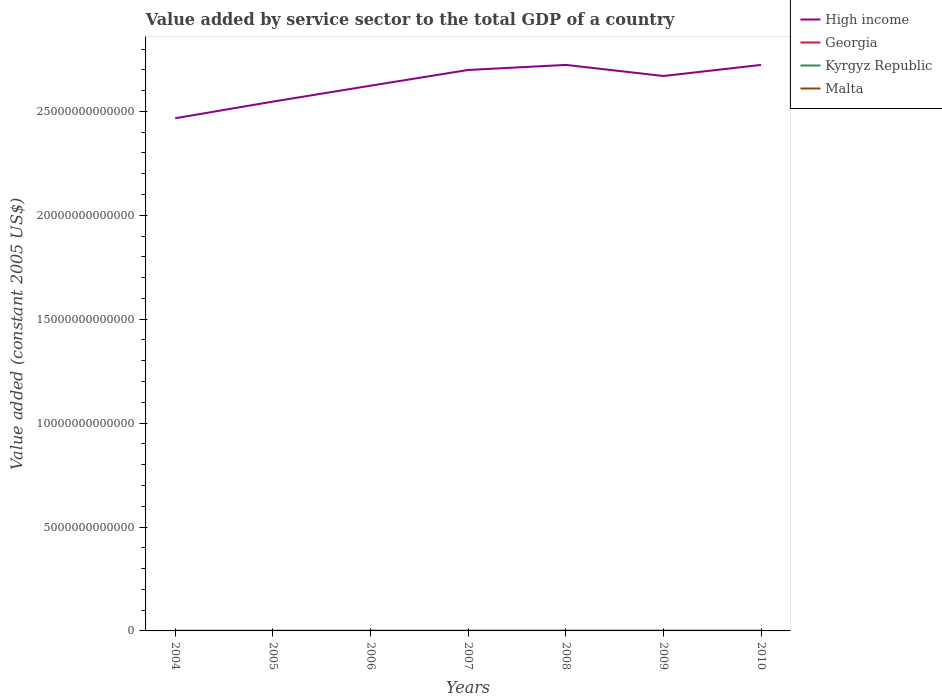Across all years, what is the maximum value added by service sector in High income?
Offer a very short reply. 2.47e+13. In which year was the value added by service sector in Kyrgyz Republic maximum?
Make the answer very short. 2004. What is the total value added by service sector in Kyrgyz Republic in the graph?
Provide a short and direct response. -6.95e+08. What is the difference between the highest and the second highest value added by service sector in High income?
Provide a succinct answer. 2.57e+12. What is the difference between the highest and the lowest value added by service sector in Malta?
Make the answer very short. 3. Is the value added by service sector in Kyrgyz Republic strictly greater than the value added by service sector in High income over the years?
Provide a short and direct response. Yes. How many lines are there?
Make the answer very short. 4. How many years are there in the graph?
Offer a terse response. 7. What is the difference between two consecutive major ticks on the Y-axis?
Keep it short and to the point. 5.00e+12. Where does the legend appear in the graph?
Your answer should be very brief. Top right. How many legend labels are there?
Your answer should be compact. 4. What is the title of the graph?
Offer a terse response. Value added by service sector to the total GDP of a country. What is the label or title of the Y-axis?
Ensure brevity in your answer.  Value added (constant 2005 US$). What is the Value added (constant 2005 US$) in High income in 2004?
Your answer should be very brief. 2.47e+13. What is the Value added (constant 2005 US$) of Georgia in 2004?
Offer a terse response. 2.95e+09. What is the Value added (constant 2005 US$) in Kyrgyz Republic in 2004?
Offer a very short reply. 9.07e+08. What is the Value added (constant 2005 US$) of Malta in 2004?
Your answer should be very brief. 2.93e+09. What is the Value added (constant 2005 US$) in High income in 2005?
Your answer should be very brief. 2.55e+13. What is the Value added (constant 2005 US$) in Georgia in 2005?
Offer a very short reply. 3.20e+09. What is the Value added (constant 2005 US$) of Kyrgyz Republic in 2005?
Offer a very short reply. 1.00e+09. What is the Value added (constant 2005 US$) in Malta in 2005?
Make the answer very short. 3.08e+09. What is the Value added (constant 2005 US$) in High income in 2006?
Your response must be concise. 2.62e+13. What is the Value added (constant 2005 US$) in Georgia in 2006?
Your response must be concise. 3.76e+09. What is the Value added (constant 2005 US$) in Kyrgyz Republic in 2006?
Your response must be concise. 1.24e+09. What is the Value added (constant 2005 US$) in Malta in 2006?
Your answer should be very brief. 3.14e+09. What is the Value added (constant 2005 US$) in High income in 2007?
Provide a short and direct response. 2.70e+13. What is the Value added (constant 2005 US$) of Georgia in 2007?
Give a very brief answer. 4.19e+09. What is the Value added (constant 2005 US$) in Kyrgyz Republic in 2007?
Provide a short and direct response. 1.42e+09. What is the Value added (constant 2005 US$) in Malta in 2007?
Offer a terse response. 3.33e+09. What is the Value added (constant 2005 US$) in High income in 2008?
Offer a very short reply. 2.72e+13. What is the Value added (constant 2005 US$) in Georgia in 2008?
Your answer should be very brief. 4.43e+09. What is the Value added (constant 2005 US$) of Kyrgyz Republic in 2008?
Provide a short and direct response. 1.60e+09. What is the Value added (constant 2005 US$) in Malta in 2008?
Give a very brief answer. 3.62e+09. What is the Value added (constant 2005 US$) in High income in 2009?
Keep it short and to the point. 2.67e+13. What is the Value added (constant 2005 US$) in Georgia in 2009?
Your response must be concise. 4.26e+09. What is the Value added (constant 2005 US$) in Kyrgyz Republic in 2009?
Provide a succinct answer. 1.62e+09. What is the Value added (constant 2005 US$) in Malta in 2009?
Keep it short and to the point. 3.69e+09. What is the Value added (constant 2005 US$) in High income in 2010?
Give a very brief answer. 2.72e+13. What is the Value added (constant 2005 US$) in Georgia in 2010?
Ensure brevity in your answer.  4.74e+09. What is the Value added (constant 2005 US$) in Kyrgyz Republic in 2010?
Your answer should be compact. 1.62e+09. What is the Value added (constant 2005 US$) in Malta in 2010?
Offer a terse response. 3.84e+09. Across all years, what is the maximum Value added (constant 2005 US$) in High income?
Offer a terse response. 2.72e+13. Across all years, what is the maximum Value added (constant 2005 US$) in Georgia?
Offer a terse response. 4.74e+09. Across all years, what is the maximum Value added (constant 2005 US$) in Kyrgyz Republic?
Your response must be concise. 1.62e+09. Across all years, what is the maximum Value added (constant 2005 US$) in Malta?
Make the answer very short. 3.84e+09. Across all years, what is the minimum Value added (constant 2005 US$) in High income?
Keep it short and to the point. 2.47e+13. Across all years, what is the minimum Value added (constant 2005 US$) of Georgia?
Your response must be concise. 2.95e+09. Across all years, what is the minimum Value added (constant 2005 US$) of Kyrgyz Republic?
Offer a very short reply. 9.07e+08. Across all years, what is the minimum Value added (constant 2005 US$) in Malta?
Your response must be concise. 2.93e+09. What is the total Value added (constant 2005 US$) of High income in the graph?
Your answer should be compact. 1.85e+14. What is the total Value added (constant 2005 US$) in Georgia in the graph?
Provide a short and direct response. 2.75e+1. What is the total Value added (constant 2005 US$) in Kyrgyz Republic in the graph?
Make the answer very short. 9.42e+09. What is the total Value added (constant 2005 US$) in Malta in the graph?
Provide a succinct answer. 2.36e+1. What is the difference between the Value added (constant 2005 US$) in High income in 2004 and that in 2005?
Keep it short and to the point. -8.01e+11. What is the difference between the Value added (constant 2005 US$) in Georgia in 2004 and that in 2005?
Your answer should be very brief. -2.54e+08. What is the difference between the Value added (constant 2005 US$) in Kyrgyz Republic in 2004 and that in 2005?
Offer a terse response. -9.48e+07. What is the difference between the Value added (constant 2005 US$) in Malta in 2004 and that in 2005?
Your answer should be compact. -1.43e+08. What is the difference between the Value added (constant 2005 US$) of High income in 2004 and that in 2006?
Provide a short and direct response. -1.57e+12. What is the difference between the Value added (constant 2005 US$) in Georgia in 2004 and that in 2006?
Provide a succinct answer. -8.07e+08. What is the difference between the Value added (constant 2005 US$) of Kyrgyz Republic in 2004 and that in 2006?
Your answer should be compact. -3.38e+08. What is the difference between the Value added (constant 2005 US$) in Malta in 2004 and that in 2006?
Provide a succinct answer. -2.05e+08. What is the difference between the Value added (constant 2005 US$) in High income in 2004 and that in 2007?
Give a very brief answer. -2.32e+12. What is the difference between the Value added (constant 2005 US$) of Georgia in 2004 and that in 2007?
Ensure brevity in your answer.  -1.24e+09. What is the difference between the Value added (constant 2005 US$) of Kyrgyz Republic in 2004 and that in 2007?
Your answer should be very brief. -5.14e+08. What is the difference between the Value added (constant 2005 US$) in Malta in 2004 and that in 2007?
Provide a succinct answer. -3.94e+08. What is the difference between the Value added (constant 2005 US$) in High income in 2004 and that in 2008?
Make the answer very short. -2.57e+12. What is the difference between the Value added (constant 2005 US$) in Georgia in 2004 and that in 2008?
Provide a succinct answer. -1.48e+09. What is the difference between the Value added (constant 2005 US$) of Kyrgyz Republic in 2004 and that in 2008?
Provide a succinct answer. -6.95e+08. What is the difference between the Value added (constant 2005 US$) of Malta in 2004 and that in 2008?
Your answer should be very brief. -6.84e+08. What is the difference between the Value added (constant 2005 US$) in High income in 2004 and that in 2009?
Provide a short and direct response. -2.03e+12. What is the difference between the Value added (constant 2005 US$) of Georgia in 2004 and that in 2009?
Make the answer very short. -1.31e+09. What is the difference between the Value added (constant 2005 US$) in Kyrgyz Republic in 2004 and that in 2009?
Offer a very short reply. -7.13e+08. What is the difference between the Value added (constant 2005 US$) in Malta in 2004 and that in 2009?
Ensure brevity in your answer.  -7.51e+08. What is the difference between the Value added (constant 2005 US$) in High income in 2004 and that in 2010?
Offer a very short reply. -2.57e+12. What is the difference between the Value added (constant 2005 US$) of Georgia in 2004 and that in 2010?
Your answer should be compact. -1.79e+09. What is the difference between the Value added (constant 2005 US$) in Kyrgyz Republic in 2004 and that in 2010?
Offer a very short reply. -7.16e+08. What is the difference between the Value added (constant 2005 US$) in Malta in 2004 and that in 2010?
Provide a short and direct response. -9.04e+08. What is the difference between the Value added (constant 2005 US$) in High income in 2005 and that in 2006?
Your response must be concise. -7.66e+11. What is the difference between the Value added (constant 2005 US$) of Georgia in 2005 and that in 2006?
Provide a succinct answer. -5.54e+08. What is the difference between the Value added (constant 2005 US$) in Kyrgyz Republic in 2005 and that in 2006?
Provide a short and direct response. -2.43e+08. What is the difference between the Value added (constant 2005 US$) of Malta in 2005 and that in 2006?
Keep it short and to the point. -6.24e+07. What is the difference between the Value added (constant 2005 US$) in High income in 2005 and that in 2007?
Your answer should be very brief. -1.52e+12. What is the difference between the Value added (constant 2005 US$) in Georgia in 2005 and that in 2007?
Make the answer very short. -9.89e+08. What is the difference between the Value added (constant 2005 US$) in Kyrgyz Republic in 2005 and that in 2007?
Your answer should be compact. -4.19e+08. What is the difference between the Value added (constant 2005 US$) in Malta in 2005 and that in 2007?
Keep it short and to the point. -2.51e+08. What is the difference between the Value added (constant 2005 US$) in High income in 2005 and that in 2008?
Make the answer very short. -1.77e+12. What is the difference between the Value added (constant 2005 US$) of Georgia in 2005 and that in 2008?
Make the answer very short. -1.22e+09. What is the difference between the Value added (constant 2005 US$) in Kyrgyz Republic in 2005 and that in 2008?
Offer a terse response. -6.00e+08. What is the difference between the Value added (constant 2005 US$) of Malta in 2005 and that in 2008?
Give a very brief answer. -5.41e+08. What is the difference between the Value added (constant 2005 US$) of High income in 2005 and that in 2009?
Make the answer very short. -1.23e+12. What is the difference between the Value added (constant 2005 US$) in Georgia in 2005 and that in 2009?
Make the answer very short. -1.05e+09. What is the difference between the Value added (constant 2005 US$) in Kyrgyz Republic in 2005 and that in 2009?
Offer a terse response. -6.18e+08. What is the difference between the Value added (constant 2005 US$) of Malta in 2005 and that in 2009?
Provide a short and direct response. -6.08e+08. What is the difference between the Value added (constant 2005 US$) of High income in 2005 and that in 2010?
Make the answer very short. -1.77e+12. What is the difference between the Value added (constant 2005 US$) of Georgia in 2005 and that in 2010?
Your answer should be very brief. -1.53e+09. What is the difference between the Value added (constant 2005 US$) of Kyrgyz Republic in 2005 and that in 2010?
Your response must be concise. -6.21e+08. What is the difference between the Value added (constant 2005 US$) of Malta in 2005 and that in 2010?
Your answer should be very brief. -7.62e+08. What is the difference between the Value added (constant 2005 US$) in High income in 2006 and that in 2007?
Your answer should be very brief. -7.56e+11. What is the difference between the Value added (constant 2005 US$) in Georgia in 2006 and that in 2007?
Provide a succinct answer. -4.35e+08. What is the difference between the Value added (constant 2005 US$) of Kyrgyz Republic in 2006 and that in 2007?
Provide a succinct answer. -1.77e+08. What is the difference between the Value added (constant 2005 US$) in Malta in 2006 and that in 2007?
Keep it short and to the point. -1.89e+08. What is the difference between the Value added (constant 2005 US$) in High income in 2006 and that in 2008?
Offer a very short reply. -1.00e+12. What is the difference between the Value added (constant 2005 US$) in Georgia in 2006 and that in 2008?
Your answer should be very brief. -6.70e+08. What is the difference between the Value added (constant 2005 US$) in Kyrgyz Republic in 2006 and that in 2008?
Provide a short and direct response. -3.57e+08. What is the difference between the Value added (constant 2005 US$) in Malta in 2006 and that in 2008?
Ensure brevity in your answer.  -4.79e+08. What is the difference between the Value added (constant 2005 US$) of High income in 2006 and that in 2009?
Offer a terse response. -4.66e+11. What is the difference between the Value added (constant 2005 US$) of Georgia in 2006 and that in 2009?
Provide a short and direct response. -5.00e+08. What is the difference between the Value added (constant 2005 US$) of Kyrgyz Republic in 2006 and that in 2009?
Keep it short and to the point. -3.75e+08. What is the difference between the Value added (constant 2005 US$) of Malta in 2006 and that in 2009?
Your answer should be very brief. -5.46e+08. What is the difference between the Value added (constant 2005 US$) of High income in 2006 and that in 2010?
Your response must be concise. -1.00e+12. What is the difference between the Value added (constant 2005 US$) in Georgia in 2006 and that in 2010?
Make the answer very short. -9.78e+08. What is the difference between the Value added (constant 2005 US$) of Kyrgyz Republic in 2006 and that in 2010?
Provide a short and direct response. -3.79e+08. What is the difference between the Value added (constant 2005 US$) in Malta in 2006 and that in 2010?
Your answer should be compact. -6.99e+08. What is the difference between the Value added (constant 2005 US$) of High income in 2007 and that in 2008?
Keep it short and to the point. -2.44e+11. What is the difference between the Value added (constant 2005 US$) of Georgia in 2007 and that in 2008?
Your answer should be very brief. -2.35e+08. What is the difference between the Value added (constant 2005 US$) of Kyrgyz Republic in 2007 and that in 2008?
Your response must be concise. -1.81e+08. What is the difference between the Value added (constant 2005 US$) in Malta in 2007 and that in 2008?
Provide a succinct answer. -2.90e+08. What is the difference between the Value added (constant 2005 US$) of High income in 2007 and that in 2009?
Your response must be concise. 2.90e+11. What is the difference between the Value added (constant 2005 US$) in Georgia in 2007 and that in 2009?
Your answer should be very brief. -6.50e+07. What is the difference between the Value added (constant 2005 US$) of Kyrgyz Republic in 2007 and that in 2009?
Provide a succinct answer. -1.99e+08. What is the difference between the Value added (constant 2005 US$) of Malta in 2007 and that in 2009?
Offer a very short reply. -3.57e+08. What is the difference between the Value added (constant 2005 US$) in High income in 2007 and that in 2010?
Your response must be concise. -2.45e+11. What is the difference between the Value added (constant 2005 US$) of Georgia in 2007 and that in 2010?
Your answer should be compact. -5.43e+08. What is the difference between the Value added (constant 2005 US$) of Kyrgyz Republic in 2007 and that in 2010?
Make the answer very short. -2.02e+08. What is the difference between the Value added (constant 2005 US$) of Malta in 2007 and that in 2010?
Your answer should be very brief. -5.10e+08. What is the difference between the Value added (constant 2005 US$) of High income in 2008 and that in 2009?
Your response must be concise. 5.34e+11. What is the difference between the Value added (constant 2005 US$) of Georgia in 2008 and that in 2009?
Provide a short and direct response. 1.70e+08. What is the difference between the Value added (constant 2005 US$) in Kyrgyz Republic in 2008 and that in 2009?
Keep it short and to the point. -1.82e+07. What is the difference between the Value added (constant 2005 US$) of Malta in 2008 and that in 2009?
Offer a terse response. -6.71e+07. What is the difference between the Value added (constant 2005 US$) in High income in 2008 and that in 2010?
Provide a short and direct response. -1.33e+09. What is the difference between the Value added (constant 2005 US$) of Georgia in 2008 and that in 2010?
Provide a succinct answer. -3.08e+08. What is the difference between the Value added (constant 2005 US$) of Kyrgyz Republic in 2008 and that in 2010?
Offer a terse response. -2.15e+07. What is the difference between the Value added (constant 2005 US$) of Malta in 2008 and that in 2010?
Ensure brevity in your answer.  -2.20e+08. What is the difference between the Value added (constant 2005 US$) in High income in 2009 and that in 2010?
Give a very brief answer. -5.36e+11. What is the difference between the Value added (constant 2005 US$) in Georgia in 2009 and that in 2010?
Your response must be concise. -4.78e+08. What is the difference between the Value added (constant 2005 US$) in Kyrgyz Republic in 2009 and that in 2010?
Your answer should be compact. -3.38e+06. What is the difference between the Value added (constant 2005 US$) of Malta in 2009 and that in 2010?
Give a very brief answer. -1.53e+08. What is the difference between the Value added (constant 2005 US$) of High income in 2004 and the Value added (constant 2005 US$) of Georgia in 2005?
Your answer should be very brief. 2.47e+13. What is the difference between the Value added (constant 2005 US$) of High income in 2004 and the Value added (constant 2005 US$) of Kyrgyz Republic in 2005?
Provide a succinct answer. 2.47e+13. What is the difference between the Value added (constant 2005 US$) of High income in 2004 and the Value added (constant 2005 US$) of Malta in 2005?
Ensure brevity in your answer.  2.47e+13. What is the difference between the Value added (constant 2005 US$) in Georgia in 2004 and the Value added (constant 2005 US$) in Kyrgyz Republic in 2005?
Offer a terse response. 1.95e+09. What is the difference between the Value added (constant 2005 US$) in Georgia in 2004 and the Value added (constant 2005 US$) in Malta in 2005?
Offer a very short reply. -1.27e+08. What is the difference between the Value added (constant 2005 US$) of Kyrgyz Republic in 2004 and the Value added (constant 2005 US$) of Malta in 2005?
Keep it short and to the point. -2.17e+09. What is the difference between the Value added (constant 2005 US$) in High income in 2004 and the Value added (constant 2005 US$) in Georgia in 2006?
Your answer should be compact. 2.47e+13. What is the difference between the Value added (constant 2005 US$) in High income in 2004 and the Value added (constant 2005 US$) in Kyrgyz Republic in 2006?
Your answer should be very brief. 2.47e+13. What is the difference between the Value added (constant 2005 US$) in High income in 2004 and the Value added (constant 2005 US$) in Malta in 2006?
Your response must be concise. 2.47e+13. What is the difference between the Value added (constant 2005 US$) in Georgia in 2004 and the Value added (constant 2005 US$) in Kyrgyz Republic in 2006?
Keep it short and to the point. 1.71e+09. What is the difference between the Value added (constant 2005 US$) of Georgia in 2004 and the Value added (constant 2005 US$) of Malta in 2006?
Make the answer very short. -1.89e+08. What is the difference between the Value added (constant 2005 US$) in Kyrgyz Republic in 2004 and the Value added (constant 2005 US$) in Malta in 2006?
Offer a terse response. -2.23e+09. What is the difference between the Value added (constant 2005 US$) of High income in 2004 and the Value added (constant 2005 US$) of Georgia in 2007?
Your answer should be very brief. 2.47e+13. What is the difference between the Value added (constant 2005 US$) in High income in 2004 and the Value added (constant 2005 US$) in Kyrgyz Republic in 2007?
Your response must be concise. 2.47e+13. What is the difference between the Value added (constant 2005 US$) in High income in 2004 and the Value added (constant 2005 US$) in Malta in 2007?
Make the answer very short. 2.47e+13. What is the difference between the Value added (constant 2005 US$) in Georgia in 2004 and the Value added (constant 2005 US$) in Kyrgyz Republic in 2007?
Keep it short and to the point. 1.53e+09. What is the difference between the Value added (constant 2005 US$) of Georgia in 2004 and the Value added (constant 2005 US$) of Malta in 2007?
Provide a succinct answer. -3.78e+08. What is the difference between the Value added (constant 2005 US$) in Kyrgyz Republic in 2004 and the Value added (constant 2005 US$) in Malta in 2007?
Your answer should be very brief. -2.42e+09. What is the difference between the Value added (constant 2005 US$) of High income in 2004 and the Value added (constant 2005 US$) of Georgia in 2008?
Make the answer very short. 2.47e+13. What is the difference between the Value added (constant 2005 US$) of High income in 2004 and the Value added (constant 2005 US$) of Kyrgyz Republic in 2008?
Keep it short and to the point. 2.47e+13. What is the difference between the Value added (constant 2005 US$) in High income in 2004 and the Value added (constant 2005 US$) in Malta in 2008?
Your answer should be very brief. 2.47e+13. What is the difference between the Value added (constant 2005 US$) of Georgia in 2004 and the Value added (constant 2005 US$) of Kyrgyz Republic in 2008?
Offer a very short reply. 1.35e+09. What is the difference between the Value added (constant 2005 US$) in Georgia in 2004 and the Value added (constant 2005 US$) in Malta in 2008?
Your answer should be very brief. -6.68e+08. What is the difference between the Value added (constant 2005 US$) of Kyrgyz Republic in 2004 and the Value added (constant 2005 US$) of Malta in 2008?
Keep it short and to the point. -2.71e+09. What is the difference between the Value added (constant 2005 US$) in High income in 2004 and the Value added (constant 2005 US$) in Georgia in 2009?
Give a very brief answer. 2.47e+13. What is the difference between the Value added (constant 2005 US$) of High income in 2004 and the Value added (constant 2005 US$) of Kyrgyz Republic in 2009?
Provide a succinct answer. 2.47e+13. What is the difference between the Value added (constant 2005 US$) in High income in 2004 and the Value added (constant 2005 US$) in Malta in 2009?
Offer a terse response. 2.47e+13. What is the difference between the Value added (constant 2005 US$) of Georgia in 2004 and the Value added (constant 2005 US$) of Kyrgyz Republic in 2009?
Keep it short and to the point. 1.33e+09. What is the difference between the Value added (constant 2005 US$) of Georgia in 2004 and the Value added (constant 2005 US$) of Malta in 2009?
Offer a very short reply. -7.35e+08. What is the difference between the Value added (constant 2005 US$) in Kyrgyz Republic in 2004 and the Value added (constant 2005 US$) in Malta in 2009?
Provide a short and direct response. -2.78e+09. What is the difference between the Value added (constant 2005 US$) in High income in 2004 and the Value added (constant 2005 US$) in Georgia in 2010?
Provide a short and direct response. 2.47e+13. What is the difference between the Value added (constant 2005 US$) in High income in 2004 and the Value added (constant 2005 US$) in Kyrgyz Republic in 2010?
Ensure brevity in your answer.  2.47e+13. What is the difference between the Value added (constant 2005 US$) of High income in 2004 and the Value added (constant 2005 US$) of Malta in 2010?
Your answer should be compact. 2.47e+13. What is the difference between the Value added (constant 2005 US$) in Georgia in 2004 and the Value added (constant 2005 US$) in Kyrgyz Republic in 2010?
Your answer should be compact. 1.33e+09. What is the difference between the Value added (constant 2005 US$) of Georgia in 2004 and the Value added (constant 2005 US$) of Malta in 2010?
Your response must be concise. -8.88e+08. What is the difference between the Value added (constant 2005 US$) in Kyrgyz Republic in 2004 and the Value added (constant 2005 US$) in Malta in 2010?
Offer a terse response. -2.93e+09. What is the difference between the Value added (constant 2005 US$) of High income in 2005 and the Value added (constant 2005 US$) of Georgia in 2006?
Ensure brevity in your answer.  2.55e+13. What is the difference between the Value added (constant 2005 US$) in High income in 2005 and the Value added (constant 2005 US$) in Kyrgyz Republic in 2006?
Offer a terse response. 2.55e+13. What is the difference between the Value added (constant 2005 US$) in High income in 2005 and the Value added (constant 2005 US$) in Malta in 2006?
Make the answer very short. 2.55e+13. What is the difference between the Value added (constant 2005 US$) of Georgia in 2005 and the Value added (constant 2005 US$) of Kyrgyz Republic in 2006?
Offer a very short reply. 1.96e+09. What is the difference between the Value added (constant 2005 US$) of Georgia in 2005 and the Value added (constant 2005 US$) of Malta in 2006?
Make the answer very short. 6.42e+07. What is the difference between the Value added (constant 2005 US$) of Kyrgyz Republic in 2005 and the Value added (constant 2005 US$) of Malta in 2006?
Provide a succinct answer. -2.14e+09. What is the difference between the Value added (constant 2005 US$) of High income in 2005 and the Value added (constant 2005 US$) of Georgia in 2007?
Offer a terse response. 2.55e+13. What is the difference between the Value added (constant 2005 US$) in High income in 2005 and the Value added (constant 2005 US$) in Kyrgyz Republic in 2007?
Ensure brevity in your answer.  2.55e+13. What is the difference between the Value added (constant 2005 US$) of High income in 2005 and the Value added (constant 2005 US$) of Malta in 2007?
Your answer should be very brief. 2.55e+13. What is the difference between the Value added (constant 2005 US$) of Georgia in 2005 and the Value added (constant 2005 US$) of Kyrgyz Republic in 2007?
Provide a succinct answer. 1.78e+09. What is the difference between the Value added (constant 2005 US$) in Georgia in 2005 and the Value added (constant 2005 US$) in Malta in 2007?
Provide a short and direct response. -1.25e+08. What is the difference between the Value added (constant 2005 US$) in Kyrgyz Republic in 2005 and the Value added (constant 2005 US$) in Malta in 2007?
Your response must be concise. -2.33e+09. What is the difference between the Value added (constant 2005 US$) of High income in 2005 and the Value added (constant 2005 US$) of Georgia in 2008?
Your response must be concise. 2.55e+13. What is the difference between the Value added (constant 2005 US$) of High income in 2005 and the Value added (constant 2005 US$) of Kyrgyz Republic in 2008?
Provide a short and direct response. 2.55e+13. What is the difference between the Value added (constant 2005 US$) of High income in 2005 and the Value added (constant 2005 US$) of Malta in 2008?
Offer a very short reply. 2.55e+13. What is the difference between the Value added (constant 2005 US$) in Georgia in 2005 and the Value added (constant 2005 US$) in Kyrgyz Republic in 2008?
Your answer should be very brief. 1.60e+09. What is the difference between the Value added (constant 2005 US$) of Georgia in 2005 and the Value added (constant 2005 US$) of Malta in 2008?
Give a very brief answer. -4.14e+08. What is the difference between the Value added (constant 2005 US$) in Kyrgyz Republic in 2005 and the Value added (constant 2005 US$) in Malta in 2008?
Your answer should be very brief. -2.62e+09. What is the difference between the Value added (constant 2005 US$) of High income in 2005 and the Value added (constant 2005 US$) of Georgia in 2009?
Make the answer very short. 2.55e+13. What is the difference between the Value added (constant 2005 US$) of High income in 2005 and the Value added (constant 2005 US$) of Kyrgyz Republic in 2009?
Keep it short and to the point. 2.55e+13. What is the difference between the Value added (constant 2005 US$) of High income in 2005 and the Value added (constant 2005 US$) of Malta in 2009?
Your answer should be very brief. 2.55e+13. What is the difference between the Value added (constant 2005 US$) of Georgia in 2005 and the Value added (constant 2005 US$) of Kyrgyz Republic in 2009?
Provide a short and direct response. 1.58e+09. What is the difference between the Value added (constant 2005 US$) of Georgia in 2005 and the Value added (constant 2005 US$) of Malta in 2009?
Keep it short and to the point. -4.82e+08. What is the difference between the Value added (constant 2005 US$) in Kyrgyz Republic in 2005 and the Value added (constant 2005 US$) in Malta in 2009?
Your answer should be compact. -2.68e+09. What is the difference between the Value added (constant 2005 US$) of High income in 2005 and the Value added (constant 2005 US$) of Georgia in 2010?
Provide a succinct answer. 2.55e+13. What is the difference between the Value added (constant 2005 US$) in High income in 2005 and the Value added (constant 2005 US$) in Kyrgyz Republic in 2010?
Your answer should be very brief. 2.55e+13. What is the difference between the Value added (constant 2005 US$) in High income in 2005 and the Value added (constant 2005 US$) in Malta in 2010?
Offer a very short reply. 2.55e+13. What is the difference between the Value added (constant 2005 US$) of Georgia in 2005 and the Value added (constant 2005 US$) of Kyrgyz Republic in 2010?
Your answer should be compact. 1.58e+09. What is the difference between the Value added (constant 2005 US$) of Georgia in 2005 and the Value added (constant 2005 US$) of Malta in 2010?
Your answer should be compact. -6.35e+08. What is the difference between the Value added (constant 2005 US$) in Kyrgyz Republic in 2005 and the Value added (constant 2005 US$) in Malta in 2010?
Your response must be concise. -2.84e+09. What is the difference between the Value added (constant 2005 US$) of High income in 2006 and the Value added (constant 2005 US$) of Georgia in 2007?
Offer a terse response. 2.62e+13. What is the difference between the Value added (constant 2005 US$) of High income in 2006 and the Value added (constant 2005 US$) of Kyrgyz Republic in 2007?
Provide a succinct answer. 2.62e+13. What is the difference between the Value added (constant 2005 US$) of High income in 2006 and the Value added (constant 2005 US$) of Malta in 2007?
Ensure brevity in your answer.  2.62e+13. What is the difference between the Value added (constant 2005 US$) in Georgia in 2006 and the Value added (constant 2005 US$) in Kyrgyz Republic in 2007?
Make the answer very short. 2.34e+09. What is the difference between the Value added (constant 2005 US$) in Georgia in 2006 and the Value added (constant 2005 US$) in Malta in 2007?
Make the answer very short. 4.29e+08. What is the difference between the Value added (constant 2005 US$) in Kyrgyz Republic in 2006 and the Value added (constant 2005 US$) in Malta in 2007?
Offer a terse response. -2.08e+09. What is the difference between the Value added (constant 2005 US$) of High income in 2006 and the Value added (constant 2005 US$) of Georgia in 2008?
Keep it short and to the point. 2.62e+13. What is the difference between the Value added (constant 2005 US$) in High income in 2006 and the Value added (constant 2005 US$) in Kyrgyz Republic in 2008?
Your answer should be very brief. 2.62e+13. What is the difference between the Value added (constant 2005 US$) in High income in 2006 and the Value added (constant 2005 US$) in Malta in 2008?
Ensure brevity in your answer.  2.62e+13. What is the difference between the Value added (constant 2005 US$) of Georgia in 2006 and the Value added (constant 2005 US$) of Kyrgyz Republic in 2008?
Offer a terse response. 2.16e+09. What is the difference between the Value added (constant 2005 US$) of Georgia in 2006 and the Value added (constant 2005 US$) of Malta in 2008?
Offer a very short reply. 1.39e+08. What is the difference between the Value added (constant 2005 US$) of Kyrgyz Republic in 2006 and the Value added (constant 2005 US$) of Malta in 2008?
Give a very brief answer. -2.37e+09. What is the difference between the Value added (constant 2005 US$) of High income in 2006 and the Value added (constant 2005 US$) of Georgia in 2009?
Your answer should be compact. 2.62e+13. What is the difference between the Value added (constant 2005 US$) in High income in 2006 and the Value added (constant 2005 US$) in Kyrgyz Republic in 2009?
Offer a very short reply. 2.62e+13. What is the difference between the Value added (constant 2005 US$) of High income in 2006 and the Value added (constant 2005 US$) of Malta in 2009?
Provide a succinct answer. 2.62e+13. What is the difference between the Value added (constant 2005 US$) in Georgia in 2006 and the Value added (constant 2005 US$) in Kyrgyz Republic in 2009?
Offer a very short reply. 2.14e+09. What is the difference between the Value added (constant 2005 US$) in Georgia in 2006 and the Value added (constant 2005 US$) in Malta in 2009?
Give a very brief answer. 7.20e+07. What is the difference between the Value added (constant 2005 US$) of Kyrgyz Republic in 2006 and the Value added (constant 2005 US$) of Malta in 2009?
Provide a succinct answer. -2.44e+09. What is the difference between the Value added (constant 2005 US$) in High income in 2006 and the Value added (constant 2005 US$) in Georgia in 2010?
Provide a succinct answer. 2.62e+13. What is the difference between the Value added (constant 2005 US$) of High income in 2006 and the Value added (constant 2005 US$) of Kyrgyz Republic in 2010?
Provide a succinct answer. 2.62e+13. What is the difference between the Value added (constant 2005 US$) of High income in 2006 and the Value added (constant 2005 US$) of Malta in 2010?
Offer a terse response. 2.62e+13. What is the difference between the Value added (constant 2005 US$) in Georgia in 2006 and the Value added (constant 2005 US$) in Kyrgyz Republic in 2010?
Offer a terse response. 2.13e+09. What is the difference between the Value added (constant 2005 US$) of Georgia in 2006 and the Value added (constant 2005 US$) of Malta in 2010?
Offer a very short reply. -8.14e+07. What is the difference between the Value added (constant 2005 US$) in Kyrgyz Republic in 2006 and the Value added (constant 2005 US$) in Malta in 2010?
Provide a short and direct response. -2.59e+09. What is the difference between the Value added (constant 2005 US$) of High income in 2007 and the Value added (constant 2005 US$) of Georgia in 2008?
Provide a succinct answer. 2.70e+13. What is the difference between the Value added (constant 2005 US$) in High income in 2007 and the Value added (constant 2005 US$) in Kyrgyz Republic in 2008?
Your response must be concise. 2.70e+13. What is the difference between the Value added (constant 2005 US$) of High income in 2007 and the Value added (constant 2005 US$) of Malta in 2008?
Your answer should be very brief. 2.70e+13. What is the difference between the Value added (constant 2005 US$) in Georgia in 2007 and the Value added (constant 2005 US$) in Kyrgyz Republic in 2008?
Your response must be concise. 2.59e+09. What is the difference between the Value added (constant 2005 US$) of Georgia in 2007 and the Value added (constant 2005 US$) of Malta in 2008?
Your response must be concise. 5.74e+08. What is the difference between the Value added (constant 2005 US$) of Kyrgyz Republic in 2007 and the Value added (constant 2005 US$) of Malta in 2008?
Your answer should be very brief. -2.20e+09. What is the difference between the Value added (constant 2005 US$) of High income in 2007 and the Value added (constant 2005 US$) of Georgia in 2009?
Keep it short and to the point. 2.70e+13. What is the difference between the Value added (constant 2005 US$) of High income in 2007 and the Value added (constant 2005 US$) of Kyrgyz Republic in 2009?
Provide a succinct answer. 2.70e+13. What is the difference between the Value added (constant 2005 US$) in High income in 2007 and the Value added (constant 2005 US$) in Malta in 2009?
Ensure brevity in your answer.  2.70e+13. What is the difference between the Value added (constant 2005 US$) of Georgia in 2007 and the Value added (constant 2005 US$) of Kyrgyz Republic in 2009?
Offer a very short reply. 2.57e+09. What is the difference between the Value added (constant 2005 US$) of Georgia in 2007 and the Value added (constant 2005 US$) of Malta in 2009?
Provide a succinct answer. 5.07e+08. What is the difference between the Value added (constant 2005 US$) in Kyrgyz Republic in 2007 and the Value added (constant 2005 US$) in Malta in 2009?
Your response must be concise. -2.26e+09. What is the difference between the Value added (constant 2005 US$) of High income in 2007 and the Value added (constant 2005 US$) of Georgia in 2010?
Provide a short and direct response. 2.70e+13. What is the difference between the Value added (constant 2005 US$) in High income in 2007 and the Value added (constant 2005 US$) in Kyrgyz Republic in 2010?
Keep it short and to the point. 2.70e+13. What is the difference between the Value added (constant 2005 US$) in High income in 2007 and the Value added (constant 2005 US$) in Malta in 2010?
Make the answer very short. 2.70e+13. What is the difference between the Value added (constant 2005 US$) in Georgia in 2007 and the Value added (constant 2005 US$) in Kyrgyz Republic in 2010?
Offer a very short reply. 2.57e+09. What is the difference between the Value added (constant 2005 US$) of Georgia in 2007 and the Value added (constant 2005 US$) of Malta in 2010?
Give a very brief answer. 3.54e+08. What is the difference between the Value added (constant 2005 US$) of Kyrgyz Republic in 2007 and the Value added (constant 2005 US$) of Malta in 2010?
Your answer should be compact. -2.42e+09. What is the difference between the Value added (constant 2005 US$) of High income in 2008 and the Value added (constant 2005 US$) of Georgia in 2009?
Offer a terse response. 2.72e+13. What is the difference between the Value added (constant 2005 US$) in High income in 2008 and the Value added (constant 2005 US$) in Kyrgyz Republic in 2009?
Offer a terse response. 2.72e+13. What is the difference between the Value added (constant 2005 US$) in High income in 2008 and the Value added (constant 2005 US$) in Malta in 2009?
Your answer should be very brief. 2.72e+13. What is the difference between the Value added (constant 2005 US$) in Georgia in 2008 and the Value added (constant 2005 US$) in Kyrgyz Republic in 2009?
Offer a very short reply. 2.81e+09. What is the difference between the Value added (constant 2005 US$) in Georgia in 2008 and the Value added (constant 2005 US$) in Malta in 2009?
Offer a terse response. 7.42e+08. What is the difference between the Value added (constant 2005 US$) of Kyrgyz Republic in 2008 and the Value added (constant 2005 US$) of Malta in 2009?
Ensure brevity in your answer.  -2.08e+09. What is the difference between the Value added (constant 2005 US$) of High income in 2008 and the Value added (constant 2005 US$) of Georgia in 2010?
Your answer should be very brief. 2.72e+13. What is the difference between the Value added (constant 2005 US$) of High income in 2008 and the Value added (constant 2005 US$) of Kyrgyz Republic in 2010?
Offer a terse response. 2.72e+13. What is the difference between the Value added (constant 2005 US$) of High income in 2008 and the Value added (constant 2005 US$) of Malta in 2010?
Your answer should be compact. 2.72e+13. What is the difference between the Value added (constant 2005 US$) in Georgia in 2008 and the Value added (constant 2005 US$) in Kyrgyz Republic in 2010?
Your response must be concise. 2.80e+09. What is the difference between the Value added (constant 2005 US$) of Georgia in 2008 and the Value added (constant 2005 US$) of Malta in 2010?
Ensure brevity in your answer.  5.89e+08. What is the difference between the Value added (constant 2005 US$) of Kyrgyz Republic in 2008 and the Value added (constant 2005 US$) of Malta in 2010?
Ensure brevity in your answer.  -2.24e+09. What is the difference between the Value added (constant 2005 US$) in High income in 2009 and the Value added (constant 2005 US$) in Georgia in 2010?
Give a very brief answer. 2.67e+13. What is the difference between the Value added (constant 2005 US$) of High income in 2009 and the Value added (constant 2005 US$) of Kyrgyz Republic in 2010?
Offer a terse response. 2.67e+13. What is the difference between the Value added (constant 2005 US$) in High income in 2009 and the Value added (constant 2005 US$) in Malta in 2010?
Your answer should be compact. 2.67e+13. What is the difference between the Value added (constant 2005 US$) of Georgia in 2009 and the Value added (constant 2005 US$) of Kyrgyz Republic in 2010?
Your response must be concise. 2.63e+09. What is the difference between the Value added (constant 2005 US$) in Georgia in 2009 and the Value added (constant 2005 US$) in Malta in 2010?
Provide a short and direct response. 4.19e+08. What is the difference between the Value added (constant 2005 US$) in Kyrgyz Republic in 2009 and the Value added (constant 2005 US$) in Malta in 2010?
Your answer should be compact. -2.22e+09. What is the average Value added (constant 2005 US$) in High income per year?
Make the answer very short. 2.64e+13. What is the average Value added (constant 2005 US$) in Georgia per year?
Give a very brief answer. 3.93e+09. What is the average Value added (constant 2005 US$) in Kyrgyz Republic per year?
Your response must be concise. 1.35e+09. What is the average Value added (constant 2005 US$) of Malta per year?
Provide a short and direct response. 3.37e+09. In the year 2004, what is the difference between the Value added (constant 2005 US$) in High income and Value added (constant 2005 US$) in Georgia?
Keep it short and to the point. 2.47e+13. In the year 2004, what is the difference between the Value added (constant 2005 US$) of High income and Value added (constant 2005 US$) of Kyrgyz Republic?
Keep it short and to the point. 2.47e+13. In the year 2004, what is the difference between the Value added (constant 2005 US$) of High income and Value added (constant 2005 US$) of Malta?
Your answer should be very brief. 2.47e+13. In the year 2004, what is the difference between the Value added (constant 2005 US$) in Georgia and Value added (constant 2005 US$) in Kyrgyz Republic?
Give a very brief answer. 2.04e+09. In the year 2004, what is the difference between the Value added (constant 2005 US$) in Georgia and Value added (constant 2005 US$) in Malta?
Give a very brief answer. 1.58e+07. In the year 2004, what is the difference between the Value added (constant 2005 US$) of Kyrgyz Republic and Value added (constant 2005 US$) of Malta?
Provide a succinct answer. -2.03e+09. In the year 2005, what is the difference between the Value added (constant 2005 US$) of High income and Value added (constant 2005 US$) of Georgia?
Ensure brevity in your answer.  2.55e+13. In the year 2005, what is the difference between the Value added (constant 2005 US$) of High income and Value added (constant 2005 US$) of Kyrgyz Republic?
Your response must be concise. 2.55e+13. In the year 2005, what is the difference between the Value added (constant 2005 US$) of High income and Value added (constant 2005 US$) of Malta?
Provide a short and direct response. 2.55e+13. In the year 2005, what is the difference between the Value added (constant 2005 US$) of Georgia and Value added (constant 2005 US$) of Kyrgyz Republic?
Your answer should be compact. 2.20e+09. In the year 2005, what is the difference between the Value added (constant 2005 US$) in Georgia and Value added (constant 2005 US$) in Malta?
Your answer should be very brief. 1.27e+08. In the year 2005, what is the difference between the Value added (constant 2005 US$) of Kyrgyz Republic and Value added (constant 2005 US$) of Malta?
Provide a succinct answer. -2.08e+09. In the year 2006, what is the difference between the Value added (constant 2005 US$) in High income and Value added (constant 2005 US$) in Georgia?
Keep it short and to the point. 2.62e+13. In the year 2006, what is the difference between the Value added (constant 2005 US$) in High income and Value added (constant 2005 US$) in Kyrgyz Republic?
Your response must be concise. 2.62e+13. In the year 2006, what is the difference between the Value added (constant 2005 US$) of High income and Value added (constant 2005 US$) of Malta?
Give a very brief answer. 2.62e+13. In the year 2006, what is the difference between the Value added (constant 2005 US$) of Georgia and Value added (constant 2005 US$) of Kyrgyz Republic?
Give a very brief answer. 2.51e+09. In the year 2006, what is the difference between the Value added (constant 2005 US$) in Georgia and Value added (constant 2005 US$) in Malta?
Offer a very short reply. 6.18e+08. In the year 2006, what is the difference between the Value added (constant 2005 US$) of Kyrgyz Republic and Value added (constant 2005 US$) of Malta?
Ensure brevity in your answer.  -1.90e+09. In the year 2007, what is the difference between the Value added (constant 2005 US$) of High income and Value added (constant 2005 US$) of Georgia?
Your response must be concise. 2.70e+13. In the year 2007, what is the difference between the Value added (constant 2005 US$) of High income and Value added (constant 2005 US$) of Kyrgyz Republic?
Provide a short and direct response. 2.70e+13. In the year 2007, what is the difference between the Value added (constant 2005 US$) of High income and Value added (constant 2005 US$) of Malta?
Your response must be concise. 2.70e+13. In the year 2007, what is the difference between the Value added (constant 2005 US$) of Georgia and Value added (constant 2005 US$) of Kyrgyz Republic?
Provide a succinct answer. 2.77e+09. In the year 2007, what is the difference between the Value added (constant 2005 US$) in Georgia and Value added (constant 2005 US$) in Malta?
Make the answer very short. 8.64e+08. In the year 2007, what is the difference between the Value added (constant 2005 US$) in Kyrgyz Republic and Value added (constant 2005 US$) in Malta?
Ensure brevity in your answer.  -1.91e+09. In the year 2008, what is the difference between the Value added (constant 2005 US$) of High income and Value added (constant 2005 US$) of Georgia?
Give a very brief answer. 2.72e+13. In the year 2008, what is the difference between the Value added (constant 2005 US$) in High income and Value added (constant 2005 US$) in Kyrgyz Republic?
Ensure brevity in your answer.  2.72e+13. In the year 2008, what is the difference between the Value added (constant 2005 US$) of High income and Value added (constant 2005 US$) of Malta?
Keep it short and to the point. 2.72e+13. In the year 2008, what is the difference between the Value added (constant 2005 US$) in Georgia and Value added (constant 2005 US$) in Kyrgyz Republic?
Your response must be concise. 2.83e+09. In the year 2008, what is the difference between the Value added (constant 2005 US$) in Georgia and Value added (constant 2005 US$) in Malta?
Your answer should be compact. 8.09e+08. In the year 2008, what is the difference between the Value added (constant 2005 US$) of Kyrgyz Republic and Value added (constant 2005 US$) of Malta?
Your response must be concise. -2.02e+09. In the year 2009, what is the difference between the Value added (constant 2005 US$) in High income and Value added (constant 2005 US$) in Georgia?
Your answer should be compact. 2.67e+13. In the year 2009, what is the difference between the Value added (constant 2005 US$) of High income and Value added (constant 2005 US$) of Kyrgyz Republic?
Your answer should be very brief. 2.67e+13. In the year 2009, what is the difference between the Value added (constant 2005 US$) in High income and Value added (constant 2005 US$) in Malta?
Your response must be concise. 2.67e+13. In the year 2009, what is the difference between the Value added (constant 2005 US$) in Georgia and Value added (constant 2005 US$) in Kyrgyz Republic?
Provide a succinct answer. 2.64e+09. In the year 2009, what is the difference between the Value added (constant 2005 US$) of Georgia and Value added (constant 2005 US$) of Malta?
Provide a short and direct response. 5.72e+08. In the year 2009, what is the difference between the Value added (constant 2005 US$) of Kyrgyz Republic and Value added (constant 2005 US$) of Malta?
Provide a succinct answer. -2.07e+09. In the year 2010, what is the difference between the Value added (constant 2005 US$) of High income and Value added (constant 2005 US$) of Georgia?
Your answer should be compact. 2.72e+13. In the year 2010, what is the difference between the Value added (constant 2005 US$) of High income and Value added (constant 2005 US$) of Kyrgyz Republic?
Your answer should be very brief. 2.72e+13. In the year 2010, what is the difference between the Value added (constant 2005 US$) in High income and Value added (constant 2005 US$) in Malta?
Offer a terse response. 2.72e+13. In the year 2010, what is the difference between the Value added (constant 2005 US$) of Georgia and Value added (constant 2005 US$) of Kyrgyz Republic?
Make the answer very short. 3.11e+09. In the year 2010, what is the difference between the Value added (constant 2005 US$) of Georgia and Value added (constant 2005 US$) of Malta?
Your answer should be very brief. 8.97e+08. In the year 2010, what is the difference between the Value added (constant 2005 US$) of Kyrgyz Republic and Value added (constant 2005 US$) of Malta?
Make the answer very short. -2.22e+09. What is the ratio of the Value added (constant 2005 US$) in High income in 2004 to that in 2005?
Offer a very short reply. 0.97. What is the ratio of the Value added (constant 2005 US$) of Georgia in 2004 to that in 2005?
Keep it short and to the point. 0.92. What is the ratio of the Value added (constant 2005 US$) of Kyrgyz Republic in 2004 to that in 2005?
Offer a terse response. 0.91. What is the ratio of the Value added (constant 2005 US$) in Malta in 2004 to that in 2005?
Your response must be concise. 0.95. What is the ratio of the Value added (constant 2005 US$) in High income in 2004 to that in 2006?
Provide a short and direct response. 0.94. What is the ratio of the Value added (constant 2005 US$) of Georgia in 2004 to that in 2006?
Offer a terse response. 0.79. What is the ratio of the Value added (constant 2005 US$) of Kyrgyz Republic in 2004 to that in 2006?
Provide a short and direct response. 0.73. What is the ratio of the Value added (constant 2005 US$) in Malta in 2004 to that in 2006?
Offer a very short reply. 0.93. What is the ratio of the Value added (constant 2005 US$) of High income in 2004 to that in 2007?
Ensure brevity in your answer.  0.91. What is the ratio of the Value added (constant 2005 US$) of Georgia in 2004 to that in 2007?
Give a very brief answer. 0.7. What is the ratio of the Value added (constant 2005 US$) in Kyrgyz Republic in 2004 to that in 2007?
Your answer should be very brief. 0.64. What is the ratio of the Value added (constant 2005 US$) of Malta in 2004 to that in 2007?
Provide a succinct answer. 0.88. What is the ratio of the Value added (constant 2005 US$) in High income in 2004 to that in 2008?
Keep it short and to the point. 0.91. What is the ratio of the Value added (constant 2005 US$) in Georgia in 2004 to that in 2008?
Provide a short and direct response. 0.67. What is the ratio of the Value added (constant 2005 US$) in Kyrgyz Republic in 2004 to that in 2008?
Keep it short and to the point. 0.57. What is the ratio of the Value added (constant 2005 US$) of Malta in 2004 to that in 2008?
Provide a succinct answer. 0.81. What is the ratio of the Value added (constant 2005 US$) of High income in 2004 to that in 2009?
Offer a very short reply. 0.92. What is the ratio of the Value added (constant 2005 US$) of Georgia in 2004 to that in 2009?
Provide a short and direct response. 0.69. What is the ratio of the Value added (constant 2005 US$) in Kyrgyz Republic in 2004 to that in 2009?
Keep it short and to the point. 0.56. What is the ratio of the Value added (constant 2005 US$) in Malta in 2004 to that in 2009?
Your response must be concise. 0.8. What is the ratio of the Value added (constant 2005 US$) in High income in 2004 to that in 2010?
Provide a short and direct response. 0.91. What is the ratio of the Value added (constant 2005 US$) in Georgia in 2004 to that in 2010?
Offer a very short reply. 0.62. What is the ratio of the Value added (constant 2005 US$) of Kyrgyz Republic in 2004 to that in 2010?
Your answer should be very brief. 0.56. What is the ratio of the Value added (constant 2005 US$) in Malta in 2004 to that in 2010?
Your answer should be very brief. 0.76. What is the ratio of the Value added (constant 2005 US$) in High income in 2005 to that in 2006?
Offer a very short reply. 0.97. What is the ratio of the Value added (constant 2005 US$) of Georgia in 2005 to that in 2006?
Offer a terse response. 0.85. What is the ratio of the Value added (constant 2005 US$) in Kyrgyz Republic in 2005 to that in 2006?
Keep it short and to the point. 0.8. What is the ratio of the Value added (constant 2005 US$) in Malta in 2005 to that in 2006?
Keep it short and to the point. 0.98. What is the ratio of the Value added (constant 2005 US$) of High income in 2005 to that in 2007?
Provide a short and direct response. 0.94. What is the ratio of the Value added (constant 2005 US$) of Georgia in 2005 to that in 2007?
Ensure brevity in your answer.  0.76. What is the ratio of the Value added (constant 2005 US$) of Kyrgyz Republic in 2005 to that in 2007?
Ensure brevity in your answer.  0.7. What is the ratio of the Value added (constant 2005 US$) in Malta in 2005 to that in 2007?
Your answer should be very brief. 0.92. What is the ratio of the Value added (constant 2005 US$) in High income in 2005 to that in 2008?
Ensure brevity in your answer.  0.94. What is the ratio of the Value added (constant 2005 US$) in Georgia in 2005 to that in 2008?
Keep it short and to the point. 0.72. What is the ratio of the Value added (constant 2005 US$) of Kyrgyz Republic in 2005 to that in 2008?
Make the answer very short. 0.63. What is the ratio of the Value added (constant 2005 US$) in Malta in 2005 to that in 2008?
Provide a succinct answer. 0.85. What is the ratio of the Value added (constant 2005 US$) in High income in 2005 to that in 2009?
Offer a terse response. 0.95. What is the ratio of the Value added (constant 2005 US$) in Georgia in 2005 to that in 2009?
Ensure brevity in your answer.  0.75. What is the ratio of the Value added (constant 2005 US$) of Kyrgyz Republic in 2005 to that in 2009?
Offer a very short reply. 0.62. What is the ratio of the Value added (constant 2005 US$) in Malta in 2005 to that in 2009?
Offer a terse response. 0.83. What is the ratio of the Value added (constant 2005 US$) of High income in 2005 to that in 2010?
Provide a short and direct response. 0.94. What is the ratio of the Value added (constant 2005 US$) of Georgia in 2005 to that in 2010?
Offer a terse response. 0.68. What is the ratio of the Value added (constant 2005 US$) of Kyrgyz Republic in 2005 to that in 2010?
Keep it short and to the point. 0.62. What is the ratio of the Value added (constant 2005 US$) of Malta in 2005 to that in 2010?
Offer a terse response. 0.8. What is the ratio of the Value added (constant 2005 US$) of High income in 2006 to that in 2007?
Provide a succinct answer. 0.97. What is the ratio of the Value added (constant 2005 US$) of Georgia in 2006 to that in 2007?
Ensure brevity in your answer.  0.9. What is the ratio of the Value added (constant 2005 US$) in Kyrgyz Republic in 2006 to that in 2007?
Provide a short and direct response. 0.88. What is the ratio of the Value added (constant 2005 US$) in Malta in 2006 to that in 2007?
Keep it short and to the point. 0.94. What is the ratio of the Value added (constant 2005 US$) of High income in 2006 to that in 2008?
Offer a very short reply. 0.96. What is the ratio of the Value added (constant 2005 US$) in Georgia in 2006 to that in 2008?
Keep it short and to the point. 0.85. What is the ratio of the Value added (constant 2005 US$) in Kyrgyz Republic in 2006 to that in 2008?
Give a very brief answer. 0.78. What is the ratio of the Value added (constant 2005 US$) of Malta in 2006 to that in 2008?
Offer a very short reply. 0.87. What is the ratio of the Value added (constant 2005 US$) in High income in 2006 to that in 2009?
Your answer should be very brief. 0.98. What is the ratio of the Value added (constant 2005 US$) of Georgia in 2006 to that in 2009?
Make the answer very short. 0.88. What is the ratio of the Value added (constant 2005 US$) of Kyrgyz Republic in 2006 to that in 2009?
Your answer should be compact. 0.77. What is the ratio of the Value added (constant 2005 US$) in Malta in 2006 to that in 2009?
Offer a terse response. 0.85. What is the ratio of the Value added (constant 2005 US$) of High income in 2006 to that in 2010?
Make the answer very short. 0.96. What is the ratio of the Value added (constant 2005 US$) in Georgia in 2006 to that in 2010?
Keep it short and to the point. 0.79. What is the ratio of the Value added (constant 2005 US$) in Kyrgyz Republic in 2006 to that in 2010?
Offer a terse response. 0.77. What is the ratio of the Value added (constant 2005 US$) in Malta in 2006 to that in 2010?
Provide a short and direct response. 0.82. What is the ratio of the Value added (constant 2005 US$) of High income in 2007 to that in 2008?
Your answer should be very brief. 0.99. What is the ratio of the Value added (constant 2005 US$) in Georgia in 2007 to that in 2008?
Your response must be concise. 0.95. What is the ratio of the Value added (constant 2005 US$) of Kyrgyz Republic in 2007 to that in 2008?
Your response must be concise. 0.89. What is the ratio of the Value added (constant 2005 US$) of Malta in 2007 to that in 2008?
Keep it short and to the point. 0.92. What is the ratio of the Value added (constant 2005 US$) of High income in 2007 to that in 2009?
Offer a terse response. 1.01. What is the ratio of the Value added (constant 2005 US$) in Georgia in 2007 to that in 2009?
Offer a very short reply. 0.98. What is the ratio of the Value added (constant 2005 US$) in Kyrgyz Republic in 2007 to that in 2009?
Your answer should be very brief. 0.88. What is the ratio of the Value added (constant 2005 US$) in Malta in 2007 to that in 2009?
Offer a terse response. 0.9. What is the ratio of the Value added (constant 2005 US$) in Georgia in 2007 to that in 2010?
Keep it short and to the point. 0.89. What is the ratio of the Value added (constant 2005 US$) in Kyrgyz Republic in 2007 to that in 2010?
Offer a terse response. 0.88. What is the ratio of the Value added (constant 2005 US$) of Malta in 2007 to that in 2010?
Provide a short and direct response. 0.87. What is the ratio of the Value added (constant 2005 US$) of High income in 2008 to that in 2009?
Keep it short and to the point. 1.02. What is the ratio of the Value added (constant 2005 US$) of Georgia in 2008 to that in 2009?
Your response must be concise. 1.04. What is the ratio of the Value added (constant 2005 US$) of Malta in 2008 to that in 2009?
Provide a succinct answer. 0.98. What is the ratio of the Value added (constant 2005 US$) in High income in 2008 to that in 2010?
Your answer should be compact. 1. What is the ratio of the Value added (constant 2005 US$) of Georgia in 2008 to that in 2010?
Your answer should be very brief. 0.93. What is the ratio of the Value added (constant 2005 US$) in Kyrgyz Republic in 2008 to that in 2010?
Keep it short and to the point. 0.99. What is the ratio of the Value added (constant 2005 US$) in Malta in 2008 to that in 2010?
Your answer should be compact. 0.94. What is the ratio of the Value added (constant 2005 US$) of High income in 2009 to that in 2010?
Your answer should be very brief. 0.98. What is the ratio of the Value added (constant 2005 US$) of Georgia in 2009 to that in 2010?
Offer a very short reply. 0.9. What is the difference between the highest and the second highest Value added (constant 2005 US$) in High income?
Make the answer very short. 1.33e+09. What is the difference between the highest and the second highest Value added (constant 2005 US$) in Georgia?
Ensure brevity in your answer.  3.08e+08. What is the difference between the highest and the second highest Value added (constant 2005 US$) of Kyrgyz Republic?
Your answer should be compact. 3.38e+06. What is the difference between the highest and the second highest Value added (constant 2005 US$) in Malta?
Keep it short and to the point. 1.53e+08. What is the difference between the highest and the lowest Value added (constant 2005 US$) of High income?
Give a very brief answer. 2.57e+12. What is the difference between the highest and the lowest Value added (constant 2005 US$) in Georgia?
Your answer should be compact. 1.79e+09. What is the difference between the highest and the lowest Value added (constant 2005 US$) in Kyrgyz Republic?
Keep it short and to the point. 7.16e+08. What is the difference between the highest and the lowest Value added (constant 2005 US$) in Malta?
Keep it short and to the point. 9.04e+08. 